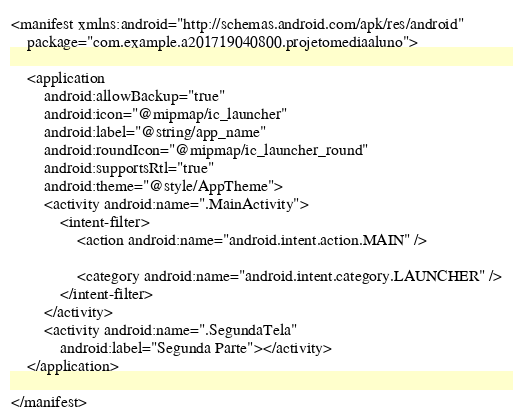<code> <loc_0><loc_0><loc_500><loc_500><_XML_><manifest xmlns:android="http://schemas.android.com/apk/res/android"
    package="com.example.a201719040800.projetomediaaluno">

    <application
        android:allowBackup="true"
        android:icon="@mipmap/ic_launcher"
        android:label="@string/app_name"
        android:roundIcon="@mipmap/ic_launcher_round"
        android:supportsRtl="true"
        android:theme="@style/AppTheme">
        <activity android:name=".MainActivity">
            <intent-filter>
                <action android:name="android.intent.action.MAIN" />

                <category android:name="android.intent.category.LAUNCHER" />
            </intent-filter>
        </activity>
        <activity android:name=".SegundaTela"
            android:label="Segunda Parte"></activity>
    </application>

</manifest></code> 